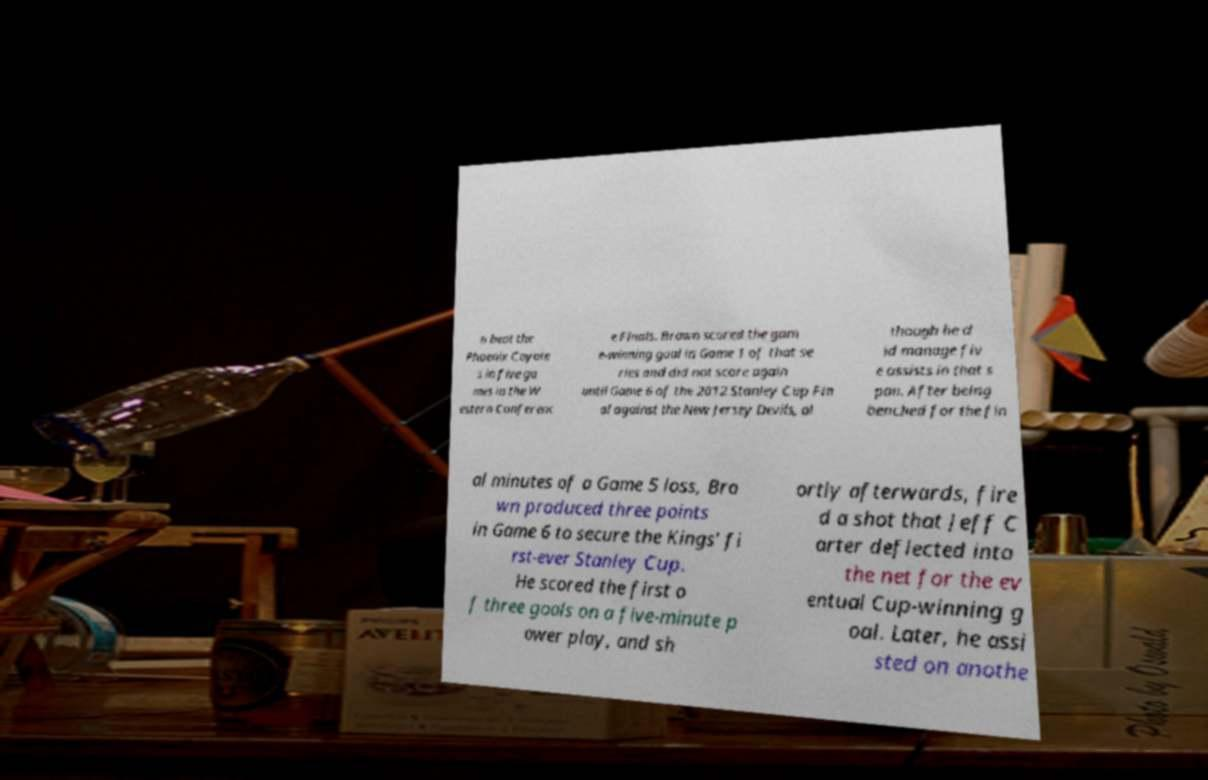Can you accurately transcribe the text from the provided image for me? n beat the Phoenix Coyote s in five ga mes in the W estern Conferenc e Finals. Brown scored the gam e-winning goal in Game 1 of that se ries and did not score again until Game 6 of the 2012 Stanley Cup Fin al against the New Jersey Devils, al though he d id manage fiv e assists in that s pan. After being benched for the fin al minutes of a Game 5 loss, Bro wn produced three points in Game 6 to secure the Kings' fi rst-ever Stanley Cup. He scored the first o f three goals on a five-minute p ower play, and sh ortly afterwards, fire d a shot that Jeff C arter deflected into the net for the ev entual Cup-winning g oal. Later, he assi sted on anothe 